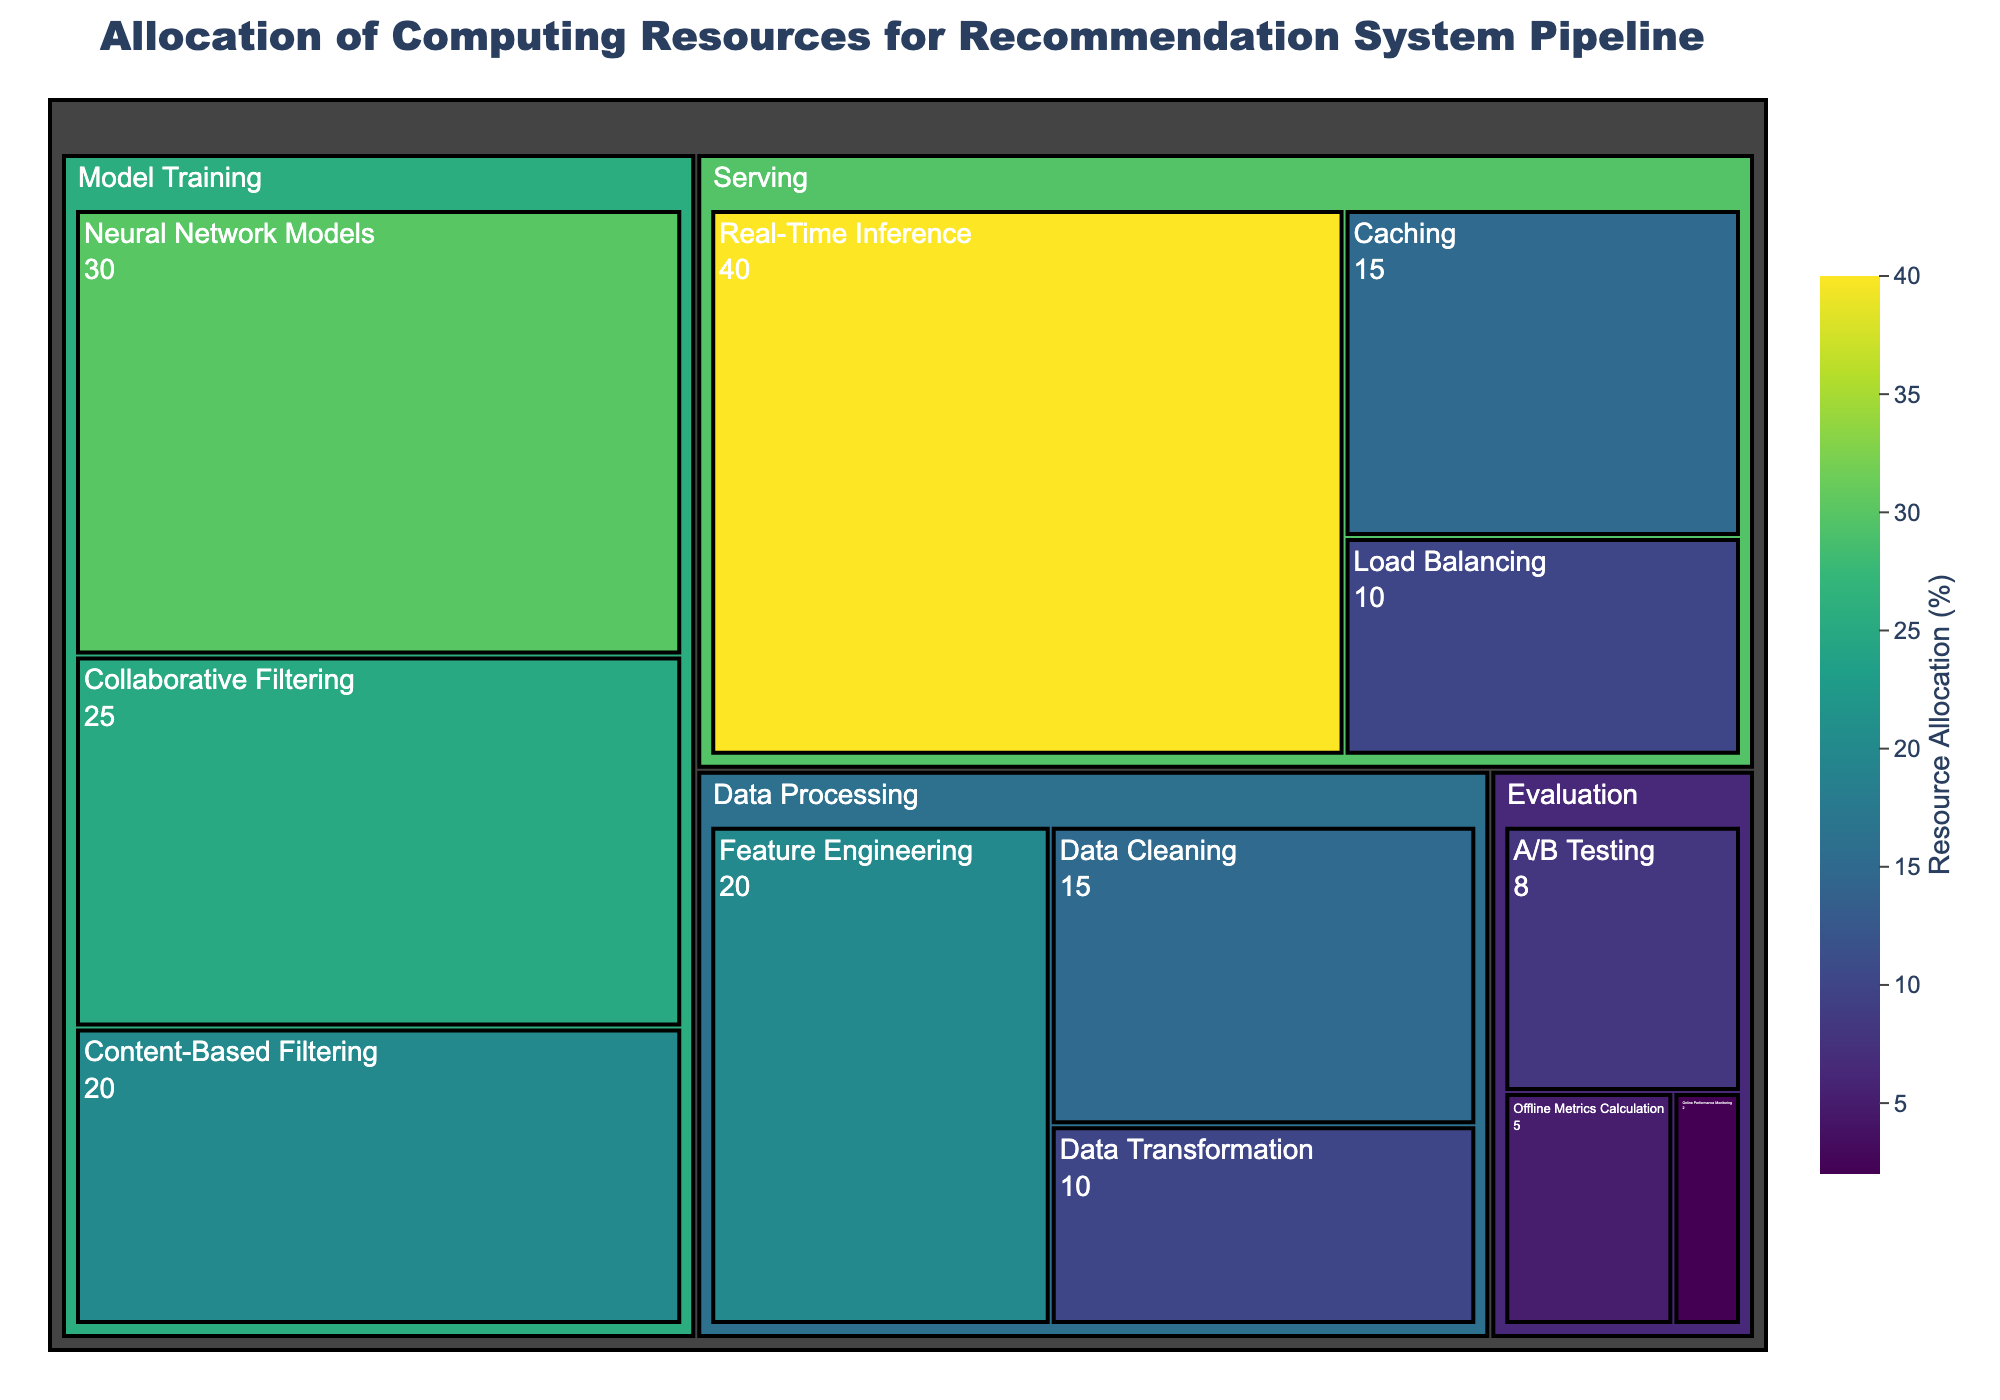What is the title of the Treemap? The title is usually located at the top center of the figure. Based on the code provided, the title should be clearly mentioned.
Answer: Allocation of Computing Resources for Recommendation System Pipeline Which stage has the highest resource allocation for a subtask? By analyzing the color intensity and labeled values, we can see that 'Serving' with 'Real-Time Inference' has the highest resource allocation.
Answer: Serving, Real-Time Inference What's the total resource allocation for the Model Training stage? By adding up the resource allocations for Collaborative Filtering (25), Content-Based Filtering (20), and Neural Network Models (30), we get the total allocation for Model Training. The sum is 25 + 20 + 30 = 75.
Answer: 75 Which subtask within Data Processing has the least resource allocation? By looking at the values within the Data Processing stage, 'Data Transformation' has the lowest allocated resources, which is 10.
Answer: Data Transformation How does the resource allocation for Data Cleaning compare to that for Load Balancing? From the Treemap, Data Cleaning has a resource allocation of 15 while Load Balancing has 10. Comparing these, 15 is greater than 10.
Answer: Data Cleaning has more resources What percentage of resources are allocated to caching? The Treemap shows 'Caching' under the 'Serving' stage with a resource allocation of 15.
Answer: 15% What is the average resource allocation for sub-tasks within the Evaluation stage? First, add up the resource allocations for A/B Testing (8), Offline Metrics Calculation (5), and Online Performance Monitoring (2). The total is 8 + 5 + 2 = 15. There are 3 sub-tasks, so the average is 15 / 3 = 5.
Answer: 5 Which stage has the most diverse range of resource allocations across its subtasks? Look at the resource allocations for each stage; Model Training has allocations of 25, 20, and 30, which shows a diverse range compared to other stages.
Answer: Model Training How much more resource is allocated to Real-Time Inference compared to Online Performance Monitoring? Real-Time Inference has a resource allocation of 40, and Online Performance Monitoring has an allocation of 2. The difference is 40 - 2 = 38.
Answer: 38 Which subtask has the least resource allocation in the entire pipeline? As seen from the Treemap, 'Online Performance Monitoring' has the lowest value of 2.
Answer: Online Performance Monitoring 